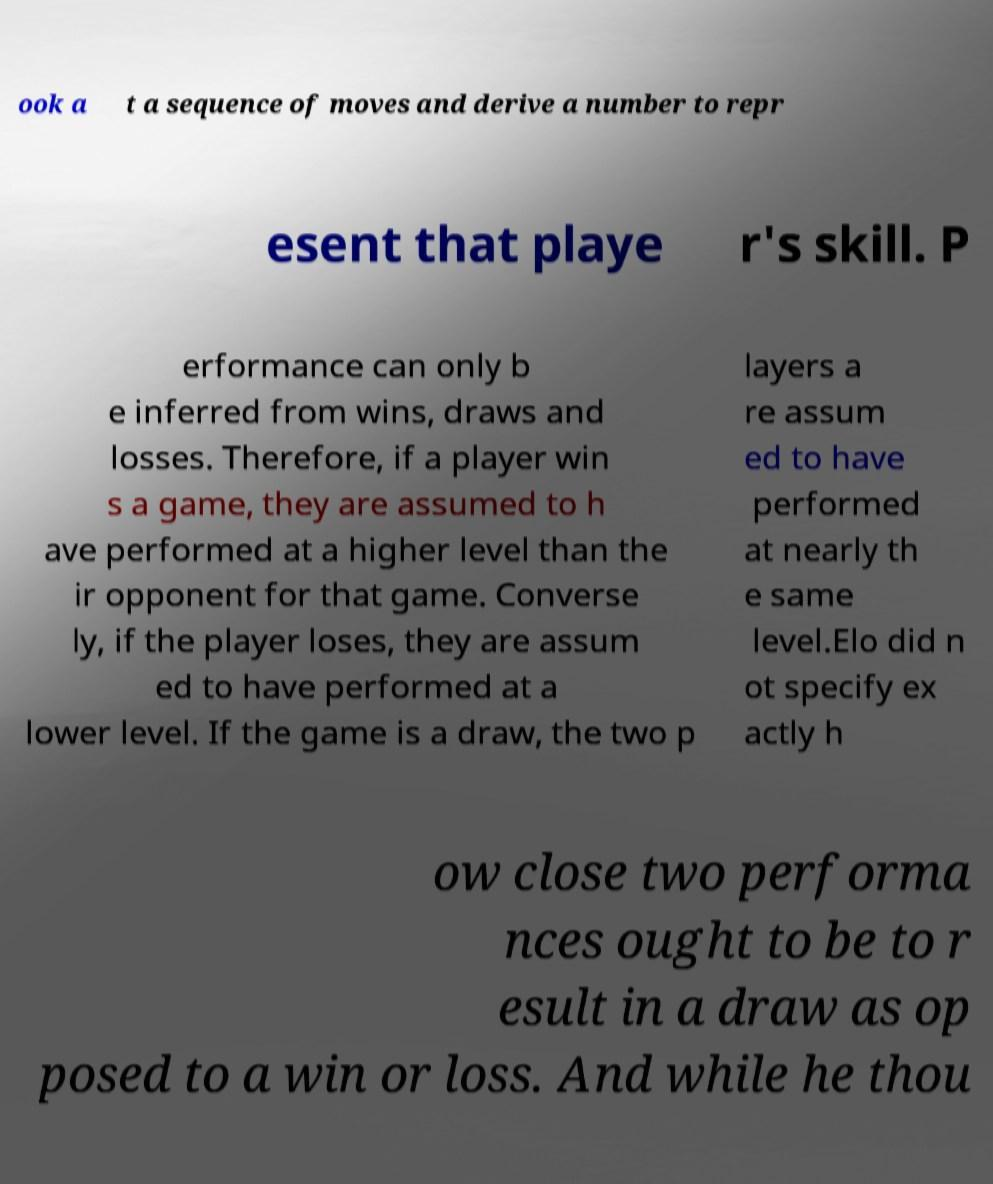Please read and relay the text visible in this image. What does it say? ook a t a sequence of moves and derive a number to repr esent that playe r's skill. P erformance can only b e inferred from wins, draws and losses. Therefore, if a player win s a game, they are assumed to h ave performed at a higher level than the ir opponent for that game. Converse ly, if the player loses, they are assum ed to have performed at a lower level. If the game is a draw, the two p layers a re assum ed to have performed at nearly th e same level.Elo did n ot specify ex actly h ow close two performa nces ought to be to r esult in a draw as op posed to a win or loss. And while he thou 